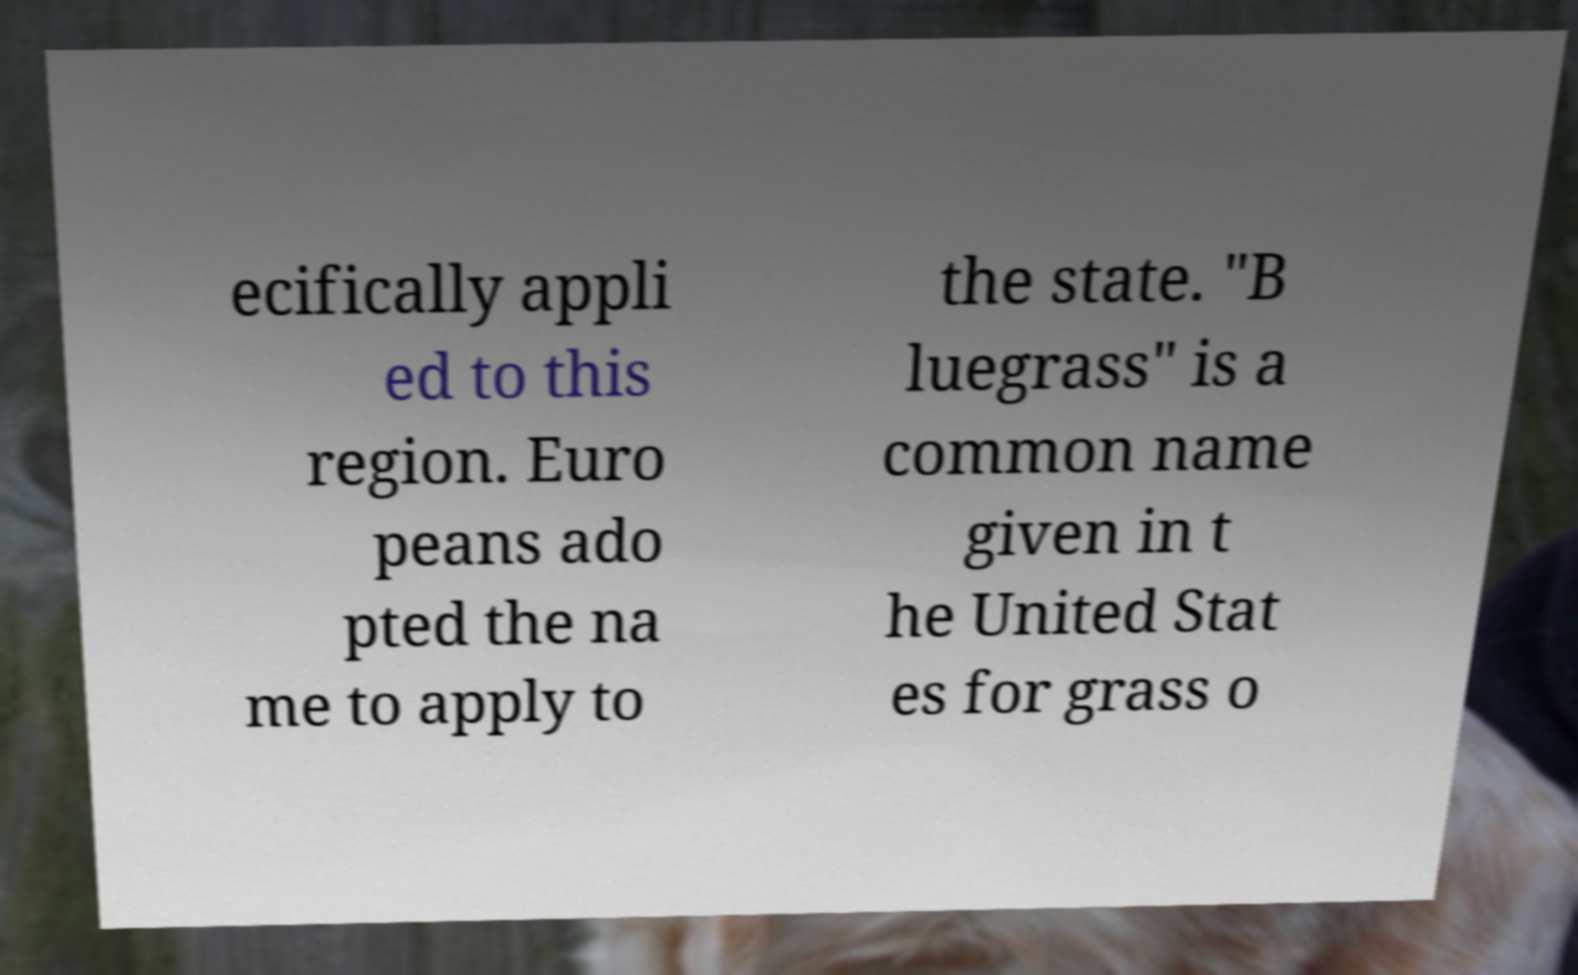Could you assist in decoding the text presented in this image and type it out clearly? ecifically appli ed to this region. Euro peans ado pted the na me to apply to the state. "B luegrass" is a common name given in t he United Stat es for grass o 